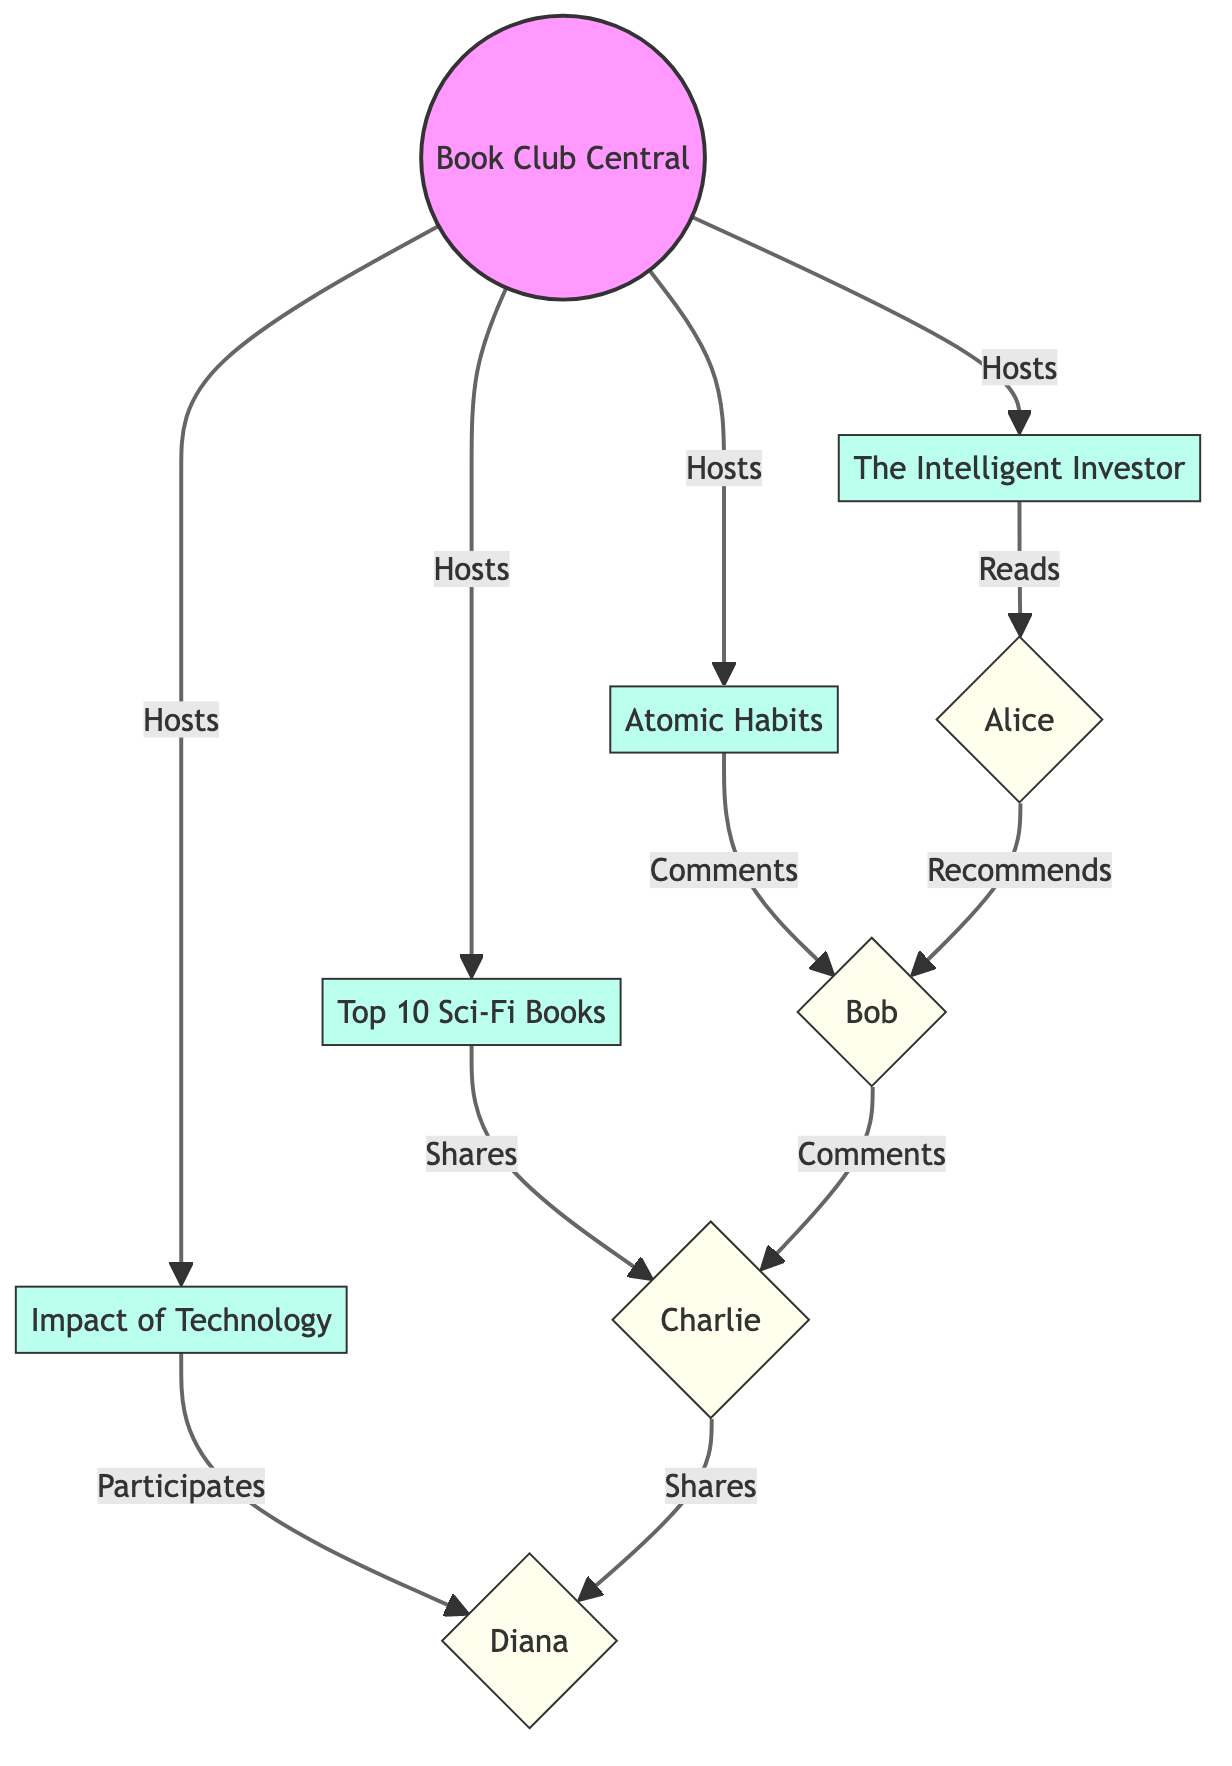What is the total number of nodes in the diagram? The diagram consists of all the nodes listed under the "nodes" section in the data provided. There are eight nodes: one central platform, four content items, and three members.
Answer: Eight Which member reads the review of 'The Intelligent Investor'? The diagram indicates that the 'Reads' interaction connects ReviewNode1 ('The Intelligent Investor') to Member1 (Alice). Therefore, Alice is the member who reads this review.
Answer: Alice How many content items are hosted by the Central Hub? By reviewing the edges that connect to the Central Hub, we see there are four edges, each connecting to a different content node indicating that the Central Hub hosts four content items.
Answer: Four Who shares the article titled 'Top 10 Must-Read Sci-Fi Books'? The article node indicates a 'Shares' interaction connecting it to Member3 (Charlie), thus Charlie is the member who shares this article.
Answer: Charlie Which member participates in the discussion about the impact of technology on literature? The edge labeled 'Participates' connecting DiscussionNode1 to Member4 (Diana) indicates that she is the one participating in this discussion.
Answer: Diana What type of content is connected to Member2? Analyzing Member2's direct connections, we observe the 'Comments' interaction from ReviewNode2 ('Atomic Habits'). This implies that the content connected to Member2 is a review.
Answer: Review How do Alice and Bob interact within the network? The diagram shows an edge between Member1 (Alice) and Member2 (Bob) indicating the interaction type 'Recommends'. Therefore, Alice recommends something to Bob.
Answer: Recommends What is the central hub of the network? The node labeled 'Central Hub' or 'Book Club Central Platform' is the centralized point of the network from which all other content flows.
Answer: Book Club Central Platform Which content item has the most direct interactions? By examining the diagram, we see that the Central Hub connects to all content items while each content item has at least one interaction with a member. Since 'DiscussionNode1' has Member4's participation, all content items are equally connected to members, indicating they share similar interaction structures.
Answer: Equal 